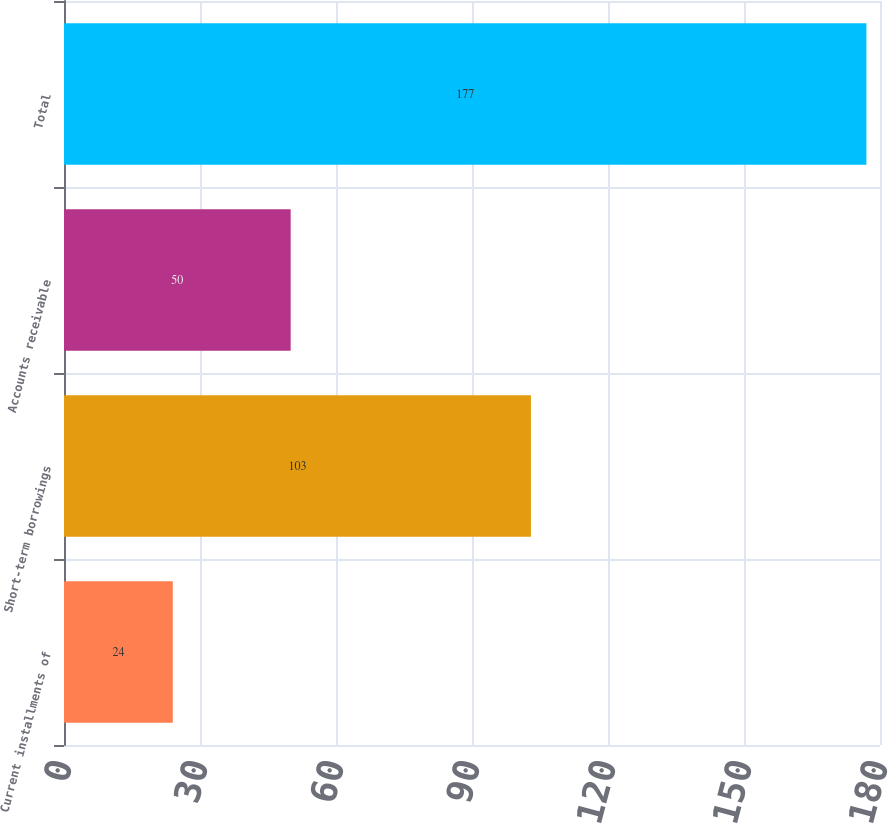Convert chart to OTSL. <chart><loc_0><loc_0><loc_500><loc_500><bar_chart><fcel>Current installments of<fcel>Short-term borrowings<fcel>Accounts receivable<fcel>Total<nl><fcel>24<fcel>103<fcel>50<fcel>177<nl></chart> 